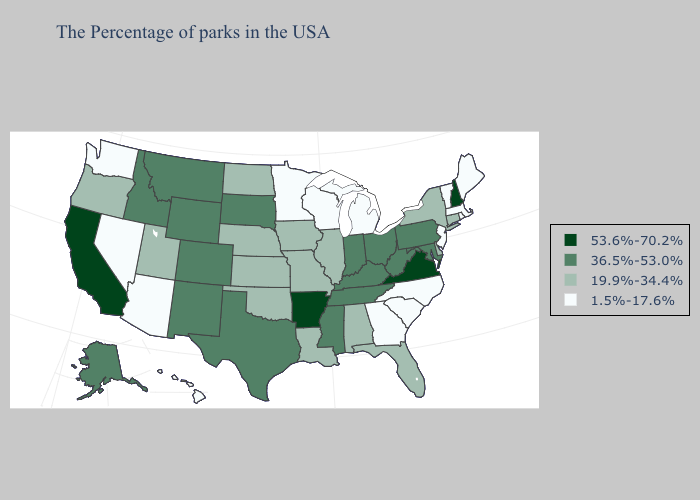Which states have the lowest value in the USA?
Keep it brief. Maine, Massachusetts, Rhode Island, Vermont, New Jersey, North Carolina, South Carolina, Georgia, Michigan, Wisconsin, Minnesota, Arizona, Nevada, Washington, Hawaii. Among the states that border Mississippi , which have the highest value?
Short answer required. Arkansas. Name the states that have a value in the range 36.5%-53.0%?
Answer briefly. Maryland, Pennsylvania, West Virginia, Ohio, Kentucky, Indiana, Tennessee, Mississippi, Texas, South Dakota, Wyoming, Colorado, New Mexico, Montana, Idaho, Alaska. Does Georgia have the highest value in the USA?
Concise answer only. No. What is the value of New Hampshire?
Keep it brief. 53.6%-70.2%. What is the lowest value in the West?
Write a very short answer. 1.5%-17.6%. Is the legend a continuous bar?
Write a very short answer. No. What is the value of Arizona?
Quick response, please. 1.5%-17.6%. Name the states that have a value in the range 53.6%-70.2%?
Give a very brief answer. New Hampshire, Virginia, Arkansas, California. What is the lowest value in the Northeast?
Be succinct. 1.5%-17.6%. Does the first symbol in the legend represent the smallest category?
Write a very short answer. No. What is the lowest value in the South?
Be succinct. 1.5%-17.6%. What is the value of Utah?
Give a very brief answer. 19.9%-34.4%. Does Maryland have the lowest value in the USA?
Keep it brief. No. What is the lowest value in the USA?
Keep it brief. 1.5%-17.6%. 